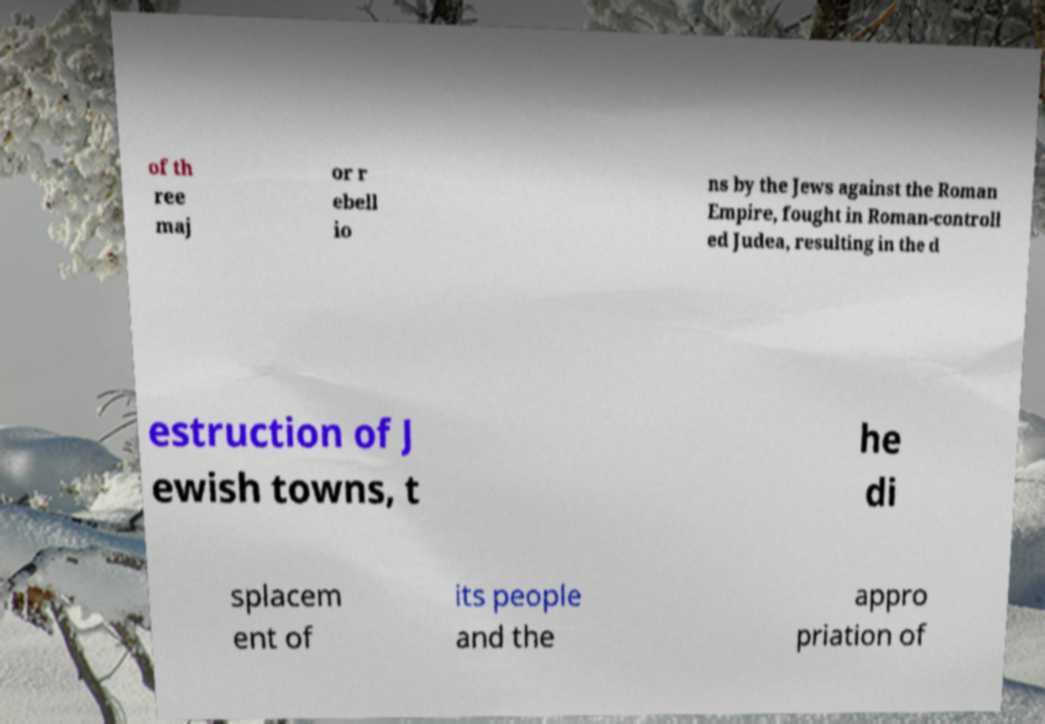For documentation purposes, I need the text within this image transcribed. Could you provide that? of th ree maj or r ebell io ns by the Jews against the Roman Empire, fought in Roman-controll ed Judea, resulting in the d estruction of J ewish towns, t he di splacem ent of its people and the appro priation of 